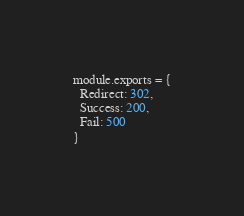Convert code to text. <code><loc_0><loc_0><loc_500><loc_500><_JavaScript_>
module.exports = {
  Redirect: 302,
  Success: 200,
  Fail: 500
}</code> 